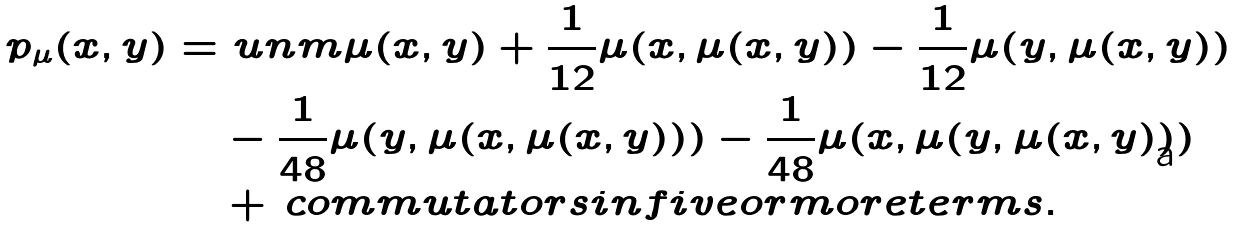Convert formula to latex. <formula><loc_0><loc_0><loc_500><loc_500>p _ { \mu } ( x , y ) = & \ u n m \mu ( x , y ) + \frac { 1 } { 1 2 } \mu ( x , \mu ( x , y ) ) - \frac { 1 } { 1 2 } \mu ( y , \mu ( x , y ) ) \\ & - \frac { 1 } { 4 8 } \mu ( y , \mu ( x , \mu ( x , y ) ) ) - \frac { 1 } { 4 8 } \mu ( x , \mu ( y , \mu ( x , y ) ) ) \\ & + \, c o m m u t a t o r s i n f i v e o r m o r e t e r m s .</formula> 